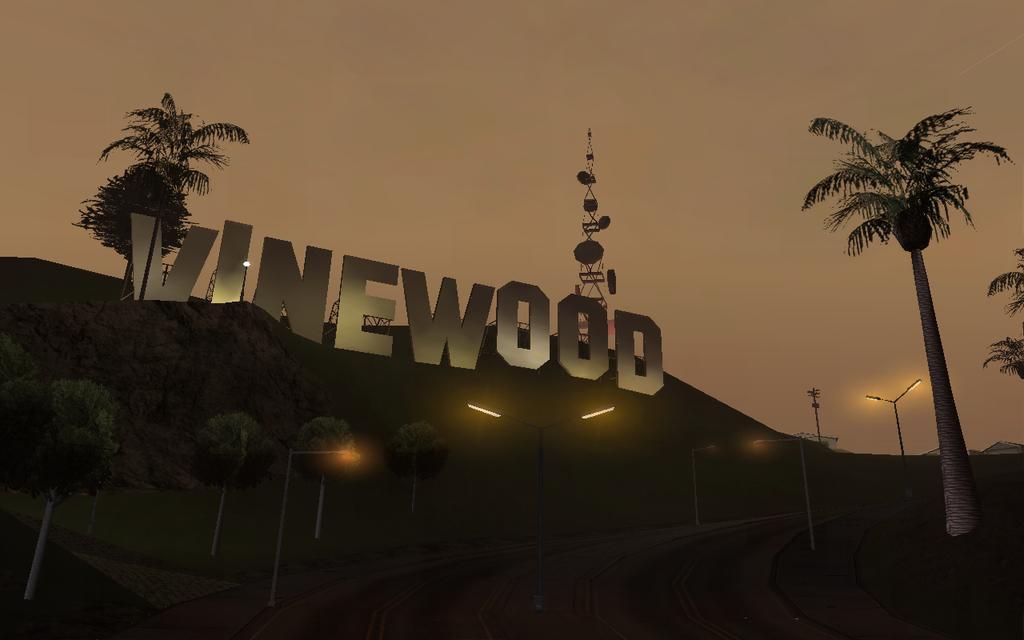Please provide a concise description of this image. In this picture I can see a hill and I can see trees and few pole lights and a tower on the hill and I can see large size of text and a cloudy sky. 